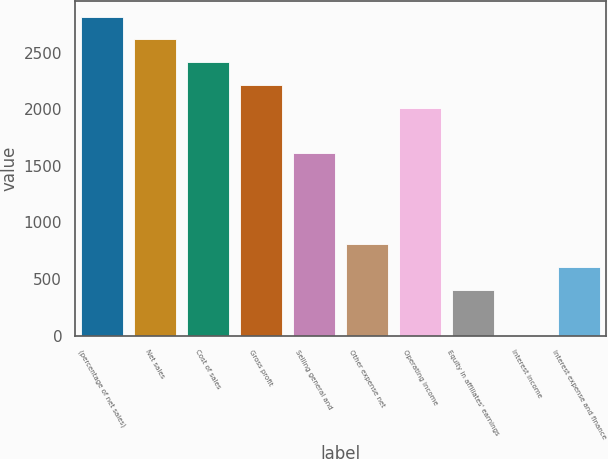Convert chart. <chart><loc_0><loc_0><loc_500><loc_500><bar_chart><fcel>(percentage of net sales)<fcel>Net sales<fcel>Cost of sales<fcel>Gross profit<fcel>Selling general and<fcel>Other expense net<fcel>Operating income<fcel>Equity in affiliates' earnings<fcel>Interest income<fcel>Interest expense and finance<nl><fcel>2820.96<fcel>2619.47<fcel>2417.98<fcel>2216.49<fcel>1612.02<fcel>806.06<fcel>2015<fcel>403.08<fcel>0.1<fcel>604.57<nl></chart> 